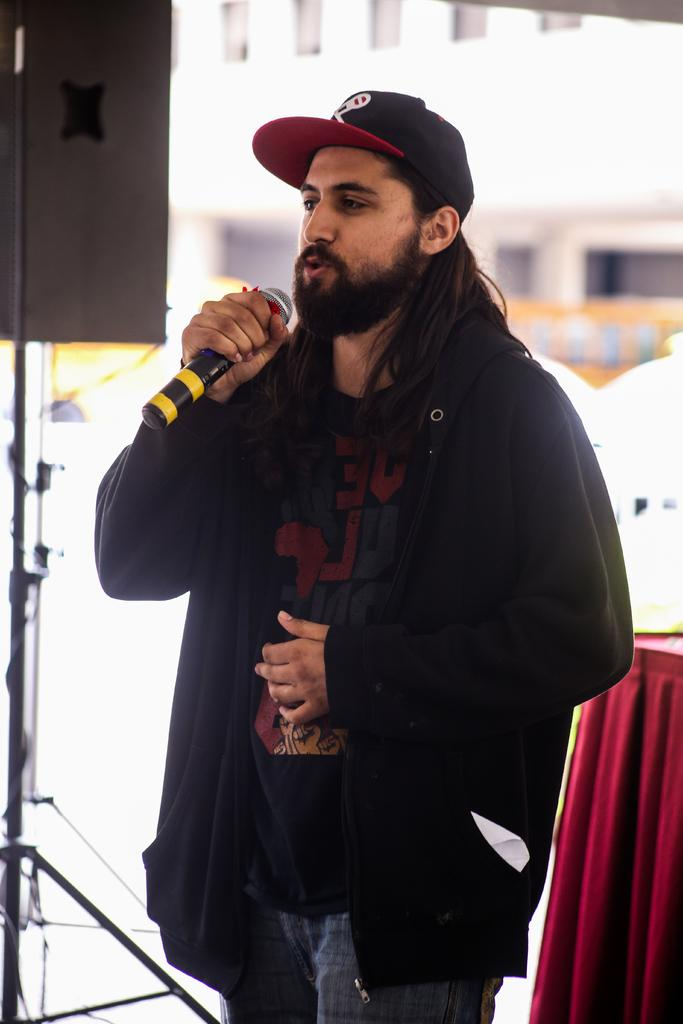What is the man in the image holding? The man is holding a microphone. What can be seen on the man's head in the image? The man is wearing a cap. What type of clothing is the man wearing on his upper body? The man is wearing a black jacket. What is visible in the background of the image? There is a building and cloth visible in the background of the image. What grade does the insect receive for its performance in the image? There is no insect present in the image, so it cannot receive a grade for its performance. 